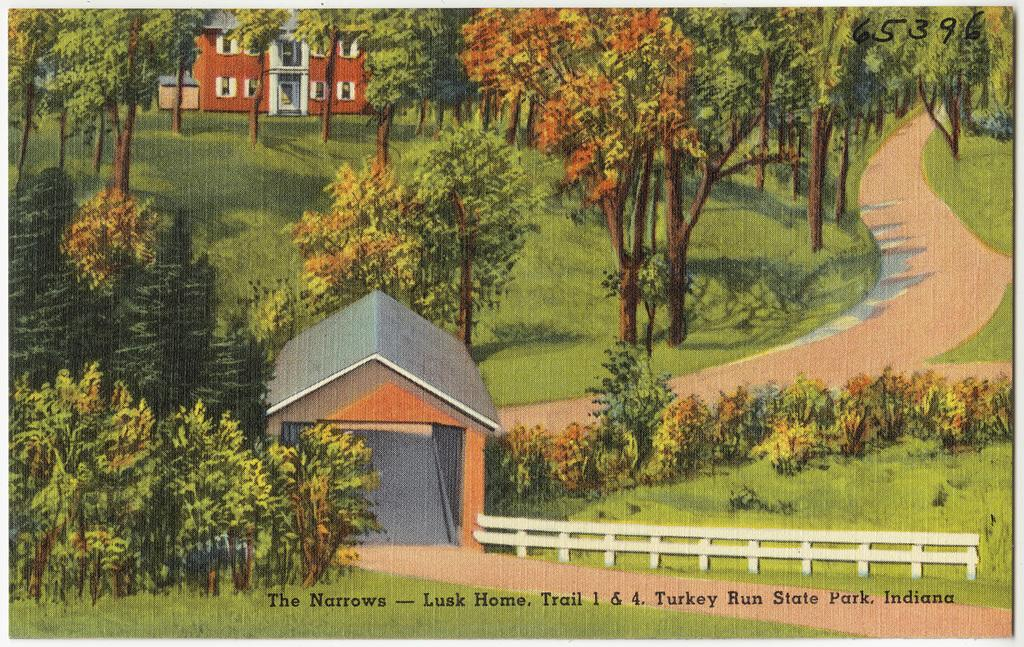What type of visual representation is shown in the image? The image is a poster. What structures are depicted in the poster? There are buildings depicted in the poster. What type of vegetation is present in the poster? Trees are present in the poster. What type of barrier is shown in the poster? There is a metal fence in the poster. What type of pathway is visible in the poster? A road is visible in the poster. What type of ground surface is shown in the poster? Grass is present on the surface in the poster. What type of fruit is hanging from the trees in the poster? There is no fruit, specifically cherries, hanging from the trees in the poster. What type of creatures can be seen crawling on the metal fence in the poster? There are no creatures, specifically spiders, crawling on the metal fence in the poster. 